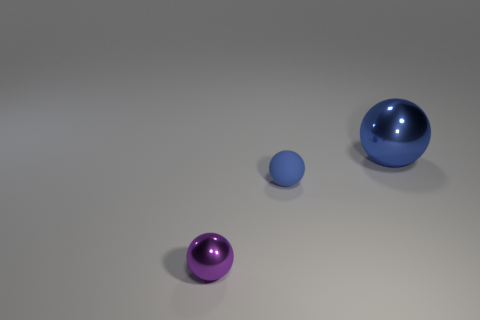There is a metal thing that is right of the small purple ball; is its shape the same as the purple shiny thing? Indeed, the metal object to the right of the small purple ball shares the same spherical shape as the shiny purple object, which is characterized by its smooth, reflective surface and perfect symmetry. 